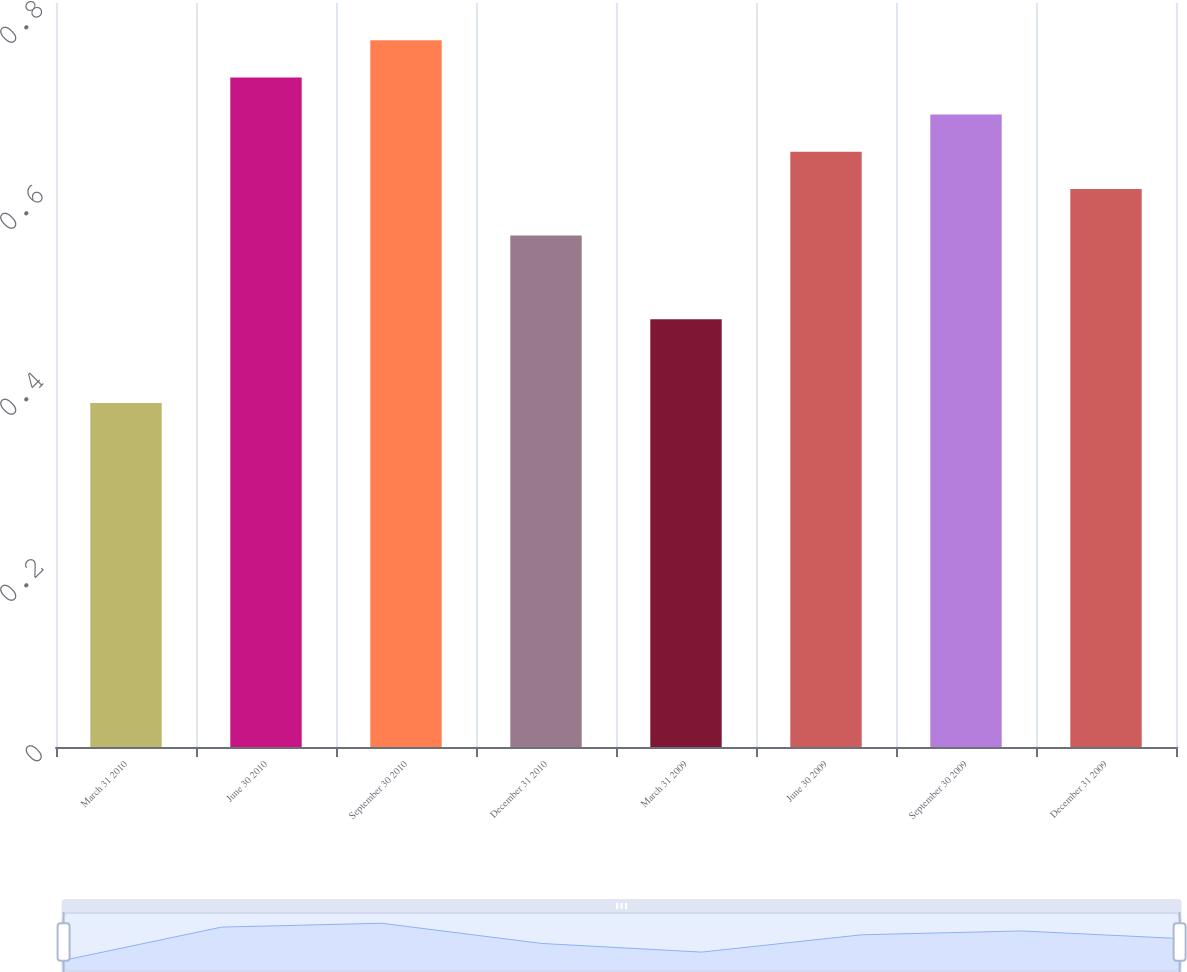Convert chart. <chart><loc_0><loc_0><loc_500><loc_500><bar_chart><fcel>March 31 2010<fcel>June 30 2010<fcel>September 30 2010<fcel>December 31 2010<fcel>March 31 2009<fcel>June 30 2009<fcel>September 30 2009<fcel>December 31 2009<nl><fcel>0.37<fcel>0.72<fcel>0.76<fcel>0.55<fcel>0.46<fcel>0.64<fcel>0.68<fcel>0.6<nl></chart> 